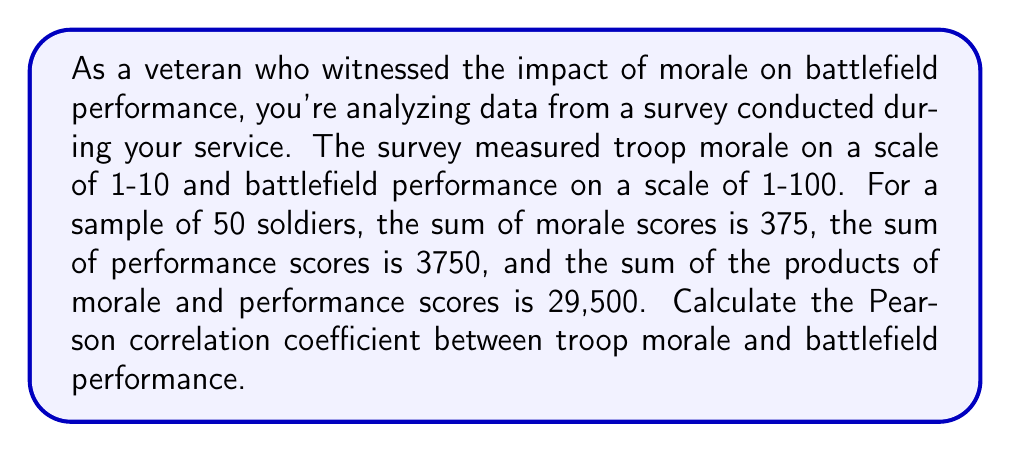Can you answer this question? To calculate the Pearson correlation coefficient, we'll use the formula:

$$ r = \frac{n\sum xy - \sum x \sum y}{\sqrt{[n\sum x^2 - (\sum x)^2][n\sum y^2 - (\sum y)^2]}} $$

Where:
$n$ = number of pairs (50)
$x$ = morale scores
$y$ = performance scores

Given:
$n = 50$
$\sum x = 375$
$\sum y = 3750$
$\sum xy = 29500$

We need to calculate $\sum x^2$ and $\sum y^2$:

$\sum x^2 = \frac{(\sum x)^2 + n\sum xy - \sum x \sum y}{n} = \frac{375^2 + 50(29500) - 375(3750)}{50} = 2906.25$

$\sum y^2 = \frac{n\sum xy - \sum x \sum y + (\sum y)^2}{n} = \frac{50(29500) - 375(3750) + 3750^2}{50} = 290625$

Now, let's substitute these values into the correlation coefficient formula:

$$ r = \frac{50(29500) - 375(3750)}{\sqrt{[50(2906.25) - 375^2][50(290625) - 3750^2]}} $$

$$ r = \frac{1475000 - 1406250}{\sqrt{[145312.5 - 140625][14531250 - 14062500]}} $$

$$ r = \frac{68750}{\sqrt{(4687.5)(468750)}} $$

$$ r = \frac{68750}{\sqrt{2197265625}} $$

$$ r = \frac{68750}{46875} $$

$$ r = 0.7333 $$
Answer: The Pearson correlation coefficient between troop morale and battlefield performance is approximately 0.7333. 